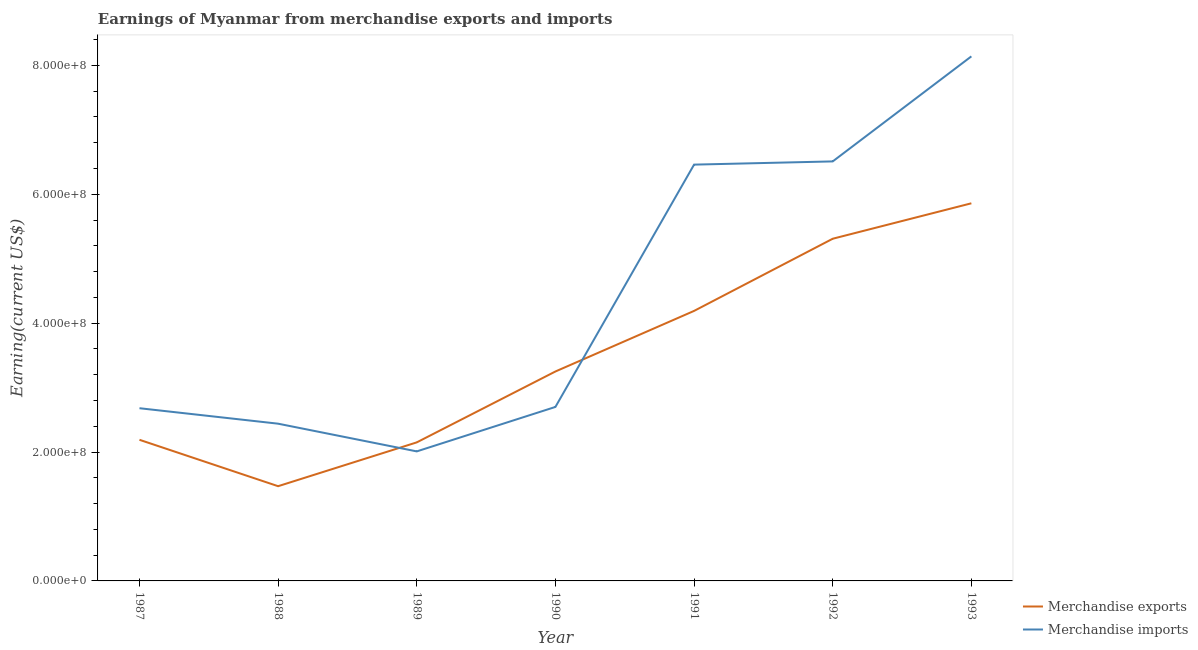How many different coloured lines are there?
Keep it short and to the point. 2. Is the number of lines equal to the number of legend labels?
Keep it short and to the point. Yes. What is the earnings from merchandise imports in 1990?
Provide a succinct answer. 2.70e+08. Across all years, what is the maximum earnings from merchandise exports?
Make the answer very short. 5.86e+08. Across all years, what is the minimum earnings from merchandise exports?
Provide a succinct answer. 1.47e+08. What is the total earnings from merchandise imports in the graph?
Your answer should be compact. 3.09e+09. What is the difference between the earnings from merchandise imports in 1989 and that in 1990?
Provide a succinct answer. -6.90e+07. What is the difference between the earnings from merchandise imports in 1988 and the earnings from merchandise exports in 1990?
Give a very brief answer. -8.10e+07. What is the average earnings from merchandise imports per year?
Make the answer very short. 4.42e+08. In the year 1991, what is the difference between the earnings from merchandise imports and earnings from merchandise exports?
Make the answer very short. 2.27e+08. In how many years, is the earnings from merchandise imports greater than 480000000 US$?
Your response must be concise. 3. What is the ratio of the earnings from merchandise exports in 1990 to that in 1993?
Your answer should be compact. 0.55. Is the earnings from merchandise exports in 1992 less than that in 1993?
Provide a short and direct response. Yes. Is the difference between the earnings from merchandise imports in 1989 and 1990 greater than the difference between the earnings from merchandise exports in 1989 and 1990?
Ensure brevity in your answer.  Yes. What is the difference between the highest and the second highest earnings from merchandise imports?
Keep it short and to the point. 1.63e+08. What is the difference between the highest and the lowest earnings from merchandise imports?
Your response must be concise. 6.13e+08. In how many years, is the earnings from merchandise exports greater than the average earnings from merchandise exports taken over all years?
Offer a terse response. 3. Is the sum of the earnings from merchandise imports in 1987 and 1989 greater than the maximum earnings from merchandise exports across all years?
Provide a short and direct response. No. Is the earnings from merchandise exports strictly greater than the earnings from merchandise imports over the years?
Your answer should be compact. No. How many lines are there?
Your answer should be very brief. 2. What is the difference between two consecutive major ticks on the Y-axis?
Make the answer very short. 2.00e+08. Does the graph contain grids?
Provide a succinct answer. No. Where does the legend appear in the graph?
Ensure brevity in your answer.  Bottom right. What is the title of the graph?
Provide a short and direct response. Earnings of Myanmar from merchandise exports and imports. Does "Start a business" appear as one of the legend labels in the graph?
Give a very brief answer. No. What is the label or title of the Y-axis?
Provide a short and direct response. Earning(current US$). What is the Earning(current US$) of Merchandise exports in 1987?
Provide a succinct answer. 2.19e+08. What is the Earning(current US$) in Merchandise imports in 1987?
Your answer should be compact. 2.68e+08. What is the Earning(current US$) of Merchandise exports in 1988?
Provide a short and direct response. 1.47e+08. What is the Earning(current US$) of Merchandise imports in 1988?
Your answer should be compact. 2.44e+08. What is the Earning(current US$) of Merchandise exports in 1989?
Keep it short and to the point. 2.15e+08. What is the Earning(current US$) of Merchandise imports in 1989?
Offer a very short reply. 2.01e+08. What is the Earning(current US$) in Merchandise exports in 1990?
Your response must be concise. 3.25e+08. What is the Earning(current US$) of Merchandise imports in 1990?
Make the answer very short. 2.70e+08. What is the Earning(current US$) in Merchandise exports in 1991?
Provide a short and direct response. 4.19e+08. What is the Earning(current US$) of Merchandise imports in 1991?
Your answer should be compact. 6.46e+08. What is the Earning(current US$) of Merchandise exports in 1992?
Provide a succinct answer. 5.31e+08. What is the Earning(current US$) in Merchandise imports in 1992?
Keep it short and to the point. 6.51e+08. What is the Earning(current US$) of Merchandise exports in 1993?
Your response must be concise. 5.86e+08. What is the Earning(current US$) in Merchandise imports in 1993?
Provide a succinct answer. 8.14e+08. Across all years, what is the maximum Earning(current US$) in Merchandise exports?
Give a very brief answer. 5.86e+08. Across all years, what is the maximum Earning(current US$) of Merchandise imports?
Make the answer very short. 8.14e+08. Across all years, what is the minimum Earning(current US$) in Merchandise exports?
Offer a terse response. 1.47e+08. Across all years, what is the minimum Earning(current US$) in Merchandise imports?
Your answer should be very brief. 2.01e+08. What is the total Earning(current US$) in Merchandise exports in the graph?
Offer a very short reply. 2.44e+09. What is the total Earning(current US$) in Merchandise imports in the graph?
Make the answer very short. 3.09e+09. What is the difference between the Earning(current US$) in Merchandise exports in 1987 and that in 1988?
Ensure brevity in your answer.  7.20e+07. What is the difference between the Earning(current US$) in Merchandise imports in 1987 and that in 1988?
Offer a very short reply. 2.40e+07. What is the difference between the Earning(current US$) in Merchandise exports in 1987 and that in 1989?
Your response must be concise. 4.00e+06. What is the difference between the Earning(current US$) of Merchandise imports in 1987 and that in 1989?
Give a very brief answer. 6.70e+07. What is the difference between the Earning(current US$) in Merchandise exports in 1987 and that in 1990?
Keep it short and to the point. -1.06e+08. What is the difference between the Earning(current US$) in Merchandise imports in 1987 and that in 1990?
Provide a short and direct response. -2.00e+06. What is the difference between the Earning(current US$) in Merchandise exports in 1987 and that in 1991?
Give a very brief answer. -2.00e+08. What is the difference between the Earning(current US$) in Merchandise imports in 1987 and that in 1991?
Provide a short and direct response. -3.78e+08. What is the difference between the Earning(current US$) in Merchandise exports in 1987 and that in 1992?
Your response must be concise. -3.12e+08. What is the difference between the Earning(current US$) in Merchandise imports in 1987 and that in 1992?
Offer a terse response. -3.83e+08. What is the difference between the Earning(current US$) of Merchandise exports in 1987 and that in 1993?
Provide a succinct answer. -3.67e+08. What is the difference between the Earning(current US$) of Merchandise imports in 1987 and that in 1993?
Offer a very short reply. -5.46e+08. What is the difference between the Earning(current US$) in Merchandise exports in 1988 and that in 1989?
Your response must be concise. -6.80e+07. What is the difference between the Earning(current US$) in Merchandise imports in 1988 and that in 1989?
Keep it short and to the point. 4.30e+07. What is the difference between the Earning(current US$) of Merchandise exports in 1988 and that in 1990?
Your answer should be compact. -1.78e+08. What is the difference between the Earning(current US$) in Merchandise imports in 1988 and that in 1990?
Your answer should be compact. -2.60e+07. What is the difference between the Earning(current US$) in Merchandise exports in 1988 and that in 1991?
Keep it short and to the point. -2.72e+08. What is the difference between the Earning(current US$) of Merchandise imports in 1988 and that in 1991?
Make the answer very short. -4.02e+08. What is the difference between the Earning(current US$) in Merchandise exports in 1988 and that in 1992?
Provide a succinct answer. -3.84e+08. What is the difference between the Earning(current US$) of Merchandise imports in 1988 and that in 1992?
Offer a very short reply. -4.07e+08. What is the difference between the Earning(current US$) of Merchandise exports in 1988 and that in 1993?
Your answer should be compact. -4.39e+08. What is the difference between the Earning(current US$) of Merchandise imports in 1988 and that in 1993?
Offer a very short reply. -5.70e+08. What is the difference between the Earning(current US$) in Merchandise exports in 1989 and that in 1990?
Provide a short and direct response. -1.10e+08. What is the difference between the Earning(current US$) in Merchandise imports in 1989 and that in 1990?
Your answer should be very brief. -6.90e+07. What is the difference between the Earning(current US$) of Merchandise exports in 1989 and that in 1991?
Offer a terse response. -2.04e+08. What is the difference between the Earning(current US$) of Merchandise imports in 1989 and that in 1991?
Keep it short and to the point. -4.45e+08. What is the difference between the Earning(current US$) of Merchandise exports in 1989 and that in 1992?
Give a very brief answer. -3.16e+08. What is the difference between the Earning(current US$) in Merchandise imports in 1989 and that in 1992?
Provide a succinct answer. -4.50e+08. What is the difference between the Earning(current US$) of Merchandise exports in 1989 and that in 1993?
Your response must be concise. -3.71e+08. What is the difference between the Earning(current US$) of Merchandise imports in 1989 and that in 1993?
Offer a very short reply. -6.13e+08. What is the difference between the Earning(current US$) in Merchandise exports in 1990 and that in 1991?
Make the answer very short. -9.40e+07. What is the difference between the Earning(current US$) in Merchandise imports in 1990 and that in 1991?
Give a very brief answer. -3.76e+08. What is the difference between the Earning(current US$) in Merchandise exports in 1990 and that in 1992?
Offer a very short reply. -2.06e+08. What is the difference between the Earning(current US$) of Merchandise imports in 1990 and that in 1992?
Offer a very short reply. -3.81e+08. What is the difference between the Earning(current US$) of Merchandise exports in 1990 and that in 1993?
Offer a very short reply. -2.61e+08. What is the difference between the Earning(current US$) in Merchandise imports in 1990 and that in 1993?
Your response must be concise. -5.44e+08. What is the difference between the Earning(current US$) in Merchandise exports in 1991 and that in 1992?
Offer a very short reply. -1.12e+08. What is the difference between the Earning(current US$) in Merchandise imports in 1991 and that in 1992?
Offer a very short reply. -5.00e+06. What is the difference between the Earning(current US$) in Merchandise exports in 1991 and that in 1993?
Provide a short and direct response. -1.67e+08. What is the difference between the Earning(current US$) of Merchandise imports in 1991 and that in 1993?
Your answer should be very brief. -1.68e+08. What is the difference between the Earning(current US$) of Merchandise exports in 1992 and that in 1993?
Give a very brief answer. -5.50e+07. What is the difference between the Earning(current US$) of Merchandise imports in 1992 and that in 1993?
Provide a short and direct response. -1.63e+08. What is the difference between the Earning(current US$) in Merchandise exports in 1987 and the Earning(current US$) in Merchandise imports in 1988?
Ensure brevity in your answer.  -2.50e+07. What is the difference between the Earning(current US$) in Merchandise exports in 1987 and the Earning(current US$) in Merchandise imports in 1989?
Provide a succinct answer. 1.80e+07. What is the difference between the Earning(current US$) in Merchandise exports in 1987 and the Earning(current US$) in Merchandise imports in 1990?
Provide a succinct answer. -5.10e+07. What is the difference between the Earning(current US$) of Merchandise exports in 1987 and the Earning(current US$) of Merchandise imports in 1991?
Make the answer very short. -4.27e+08. What is the difference between the Earning(current US$) of Merchandise exports in 1987 and the Earning(current US$) of Merchandise imports in 1992?
Keep it short and to the point. -4.32e+08. What is the difference between the Earning(current US$) of Merchandise exports in 1987 and the Earning(current US$) of Merchandise imports in 1993?
Your response must be concise. -5.95e+08. What is the difference between the Earning(current US$) in Merchandise exports in 1988 and the Earning(current US$) in Merchandise imports in 1989?
Provide a succinct answer. -5.40e+07. What is the difference between the Earning(current US$) of Merchandise exports in 1988 and the Earning(current US$) of Merchandise imports in 1990?
Make the answer very short. -1.23e+08. What is the difference between the Earning(current US$) of Merchandise exports in 1988 and the Earning(current US$) of Merchandise imports in 1991?
Provide a succinct answer. -4.99e+08. What is the difference between the Earning(current US$) of Merchandise exports in 1988 and the Earning(current US$) of Merchandise imports in 1992?
Keep it short and to the point. -5.04e+08. What is the difference between the Earning(current US$) of Merchandise exports in 1988 and the Earning(current US$) of Merchandise imports in 1993?
Your response must be concise. -6.67e+08. What is the difference between the Earning(current US$) in Merchandise exports in 1989 and the Earning(current US$) in Merchandise imports in 1990?
Make the answer very short. -5.50e+07. What is the difference between the Earning(current US$) of Merchandise exports in 1989 and the Earning(current US$) of Merchandise imports in 1991?
Keep it short and to the point. -4.31e+08. What is the difference between the Earning(current US$) of Merchandise exports in 1989 and the Earning(current US$) of Merchandise imports in 1992?
Keep it short and to the point. -4.36e+08. What is the difference between the Earning(current US$) in Merchandise exports in 1989 and the Earning(current US$) in Merchandise imports in 1993?
Offer a very short reply. -5.99e+08. What is the difference between the Earning(current US$) in Merchandise exports in 1990 and the Earning(current US$) in Merchandise imports in 1991?
Ensure brevity in your answer.  -3.21e+08. What is the difference between the Earning(current US$) of Merchandise exports in 1990 and the Earning(current US$) of Merchandise imports in 1992?
Your answer should be compact. -3.26e+08. What is the difference between the Earning(current US$) in Merchandise exports in 1990 and the Earning(current US$) in Merchandise imports in 1993?
Your response must be concise. -4.89e+08. What is the difference between the Earning(current US$) in Merchandise exports in 1991 and the Earning(current US$) in Merchandise imports in 1992?
Keep it short and to the point. -2.32e+08. What is the difference between the Earning(current US$) of Merchandise exports in 1991 and the Earning(current US$) of Merchandise imports in 1993?
Your response must be concise. -3.95e+08. What is the difference between the Earning(current US$) in Merchandise exports in 1992 and the Earning(current US$) in Merchandise imports in 1993?
Offer a very short reply. -2.83e+08. What is the average Earning(current US$) of Merchandise exports per year?
Your answer should be very brief. 3.49e+08. What is the average Earning(current US$) of Merchandise imports per year?
Your response must be concise. 4.42e+08. In the year 1987, what is the difference between the Earning(current US$) in Merchandise exports and Earning(current US$) in Merchandise imports?
Your answer should be compact. -4.90e+07. In the year 1988, what is the difference between the Earning(current US$) of Merchandise exports and Earning(current US$) of Merchandise imports?
Your response must be concise. -9.70e+07. In the year 1989, what is the difference between the Earning(current US$) of Merchandise exports and Earning(current US$) of Merchandise imports?
Make the answer very short. 1.40e+07. In the year 1990, what is the difference between the Earning(current US$) of Merchandise exports and Earning(current US$) of Merchandise imports?
Make the answer very short. 5.50e+07. In the year 1991, what is the difference between the Earning(current US$) in Merchandise exports and Earning(current US$) in Merchandise imports?
Your response must be concise. -2.27e+08. In the year 1992, what is the difference between the Earning(current US$) of Merchandise exports and Earning(current US$) of Merchandise imports?
Ensure brevity in your answer.  -1.20e+08. In the year 1993, what is the difference between the Earning(current US$) in Merchandise exports and Earning(current US$) in Merchandise imports?
Make the answer very short. -2.28e+08. What is the ratio of the Earning(current US$) of Merchandise exports in 1987 to that in 1988?
Your answer should be very brief. 1.49. What is the ratio of the Earning(current US$) of Merchandise imports in 1987 to that in 1988?
Your answer should be compact. 1.1. What is the ratio of the Earning(current US$) of Merchandise exports in 1987 to that in 1989?
Your answer should be very brief. 1.02. What is the ratio of the Earning(current US$) in Merchandise imports in 1987 to that in 1989?
Keep it short and to the point. 1.33. What is the ratio of the Earning(current US$) of Merchandise exports in 1987 to that in 1990?
Offer a terse response. 0.67. What is the ratio of the Earning(current US$) in Merchandise exports in 1987 to that in 1991?
Your answer should be very brief. 0.52. What is the ratio of the Earning(current US$) in Merchandise imports in 1987 to that in 1991?
Your answer should be compact. 0.41. What is the ratio of the Earning(current US$) in Merchandise exports in 1987 to that in 1992?
Keep it short and to the point. 0.41. What is the ratio of the Earning(current US$) of Merchandise imports in 1987 to that in 1992?
Make the answer very short. 0.41. What is the ratio of the Earning(current US$) in Merchandise exports in 1987 to that in 1993?
Give a very brief answer. 0.37. What is the ratio of the Earning(current US$) in Merchandise imports in 1987 to that in 1993?
Offer a very short reply. 0.33. What is the ratio of the Earning(current US$) of Merchandise exports in 1988 to that in 1989?
Make the answer very short. 0.68. What is the ratio of the Earning(current US$) of Merchandise imports in 1988 to that in 1989?
Offer a very short reply. 1.21. What is the ratio of the Earning(current US$) in Merchandise exports in 1988 to that in 1990?
Offer a very short reply. 0.45. What is the ratio of the Earning(current US$) of Merchandise imports in 1988 to that in 1990?
Your answer should be very brief. 0.9. What is the ratio of the Earning(current US$) of Merchandise exports in 1988 to that in 1991?
Your answer should be very brief. 0.35. What is the ratio of the Earning(current US$) in Merchandise imports in 1988 to that in 1991?
Give a very brief answer. 0.38. What is the ratio of the Earning(current US$) of Merchandise exports in 1988 to that in 1992?
Your response must be concise. 0.28. What is the ratio of the Earning(current US$) of Merchandise imports in 1988 to that in 1992?
Ensure brevity in your answer.  0.37. What is the ratio of the Earning(current US$) in Merchandise exports in 1988 to that in 1993?
Ensure brevity in your answer.  0.25. What is the ratio of the Earning(current US$) of Merchandise imports in 1988 to that in 1993?
Provide a succinct answer. 0.3. What is the ratio of the Earning(current US$) in Merchandise exports in 1989 to that in 1990?
Provide a short and direct response. 0.66. What is the ratio of the Earning(current US$) in Merchandise imports in 1989 to that in 1990?
Provide a short and direct response. 0.74. What is the ratio of the Earning(current US$) of Merchandise exports in 1989 to that in 1991?
Your response must be concise. 0.51. What is the ratio of the Earning(current US$) of Merchandise imports in 1989 to that in 1991?
Give a very brief answer. 0.31. What is the ratio of the Earning(current US$) of Merchandise exports in 1989 to that in 1992?
Give a very brief answer. 0.4. What is the ratio of the Earning(current US$) of Merchandise imports in 1989 to that in 1992?
Ensure brevity in your answer.  0.31. What is the ratio of the Earning(current US$) in Merchandise exports in 1989 to that in 1993?
Provide a short and direct response. 0.37. What is the ratio of the Earning(current US$) in Merchandise imports in 1989 to that in 1993?
Make the answer very short. 0.25. What is the ratio of the Earning(current US$) in Merchandise exports in 1990 to that in 1991?
Your response must be concise. 0.78. What is the ratio of the Earning(current US$) of Merchandise imports in 1990 to that in 1991?
Give a very brief answer. 0.42. What is the ratio of the Earning(current US$) of Merchandise exports in 1990 to that in 1992?
Offer a very short reply. 0.61. What is the ratio of the Earning(current US$) of Merchandise imports in 1990 to that in 1992?
Your answer should be compact. 0.41. What is the ratio of the Earning(current US$) in Merchandise exports in 1990 to that in 1993?
Offer a very short reply. 0.55. What is the ratio of the Earning(current US$) of Merchandise imports in 1990 to that in 1993?
Ensure brevity in your answer.  0.33. What is the ratio of the Earning(current US$) of Merchandise exports in 1991 to that in 1992?
Ensure brevity in your answer.  0.79. What is the ratio of the Earning(current US$) of Merchandise imports in 1991 to that in 1992?
Your response must be concise. 0.99. What is the ratio of the Earning(current US$) in Merchandise exports in 1991 to that in 1993?
Provide a short and direct response. 0.71. What is the ratio of the Earning(current US$) of Merchandise imports in 1991 to that in 1993?
Ensure brevity in your answer.  0.79. What is the ratio of the Earning(current US$) in Merchandise exports in 1992 to that in 1993?
Provide a short and direct response. 0.91. What is the ratio of the Earning(current US$) in Merchandise imports in 1992 to that in 1993?
Keep it short and to the point. 0.8. What is the difference between the highest and the second highest Earning(current US$) of Merchandise exports?
Your response must be concise. 5.50e+07. What is the difference between the highest and the second highest Earning(current US$) in Merchandise imports?
Provide a succinct answer. 1.63e+08. What is the difference between the highest and the lowest Earning(current US$) of Merchandise exports?
Your response must be concise. 4.39e+08. What is the difference between the highest and the lowest Earning(current US$) in Merchandise imports?
Your answer should be very brief. 6.13e+08. 